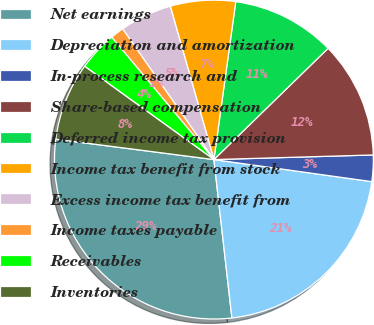Convert chart. <chart><loc_0><loc_0><loc_500><loc_500><pie_chart><fcel>Net earnings<fcel>Depreciation and amortization<fcel>In-process research and<fcel>Share-based compensation<fcel>Deferred income tax provision<fcel>Income tax benefit from stock<fcel>Excess income tax benefit from<fcel>Income taxes payable<fcel>Receivables<fcel>Inventories<nl><fcel>28.84%<fcel>20.99%<fcel>2.67%<fcel>11.83%<fcel>10.52%<fcel>6.6%<fcel>5.29%<fcel>1.37%<fcel>3.98%<fcel>7.91%<nl></chart> 